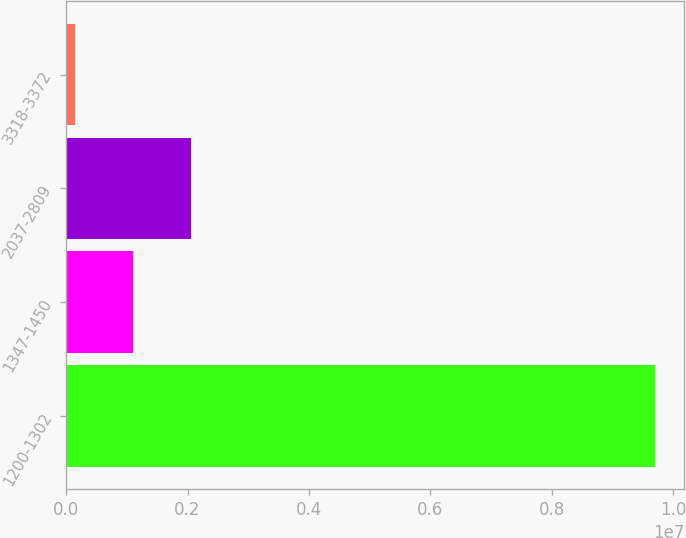Convert chart. <chart><loc_0><loc_0><loc_500><loc_500><bar_chart><fcel>1200-1302<fcel>1347-1450<fcel>2037-2809<fcel>3318-3372<nl><fcel>9.69543e+06<fcel>1.09705e+06<fcel>2.05243e+06<fcel>141675<nl></chart> 